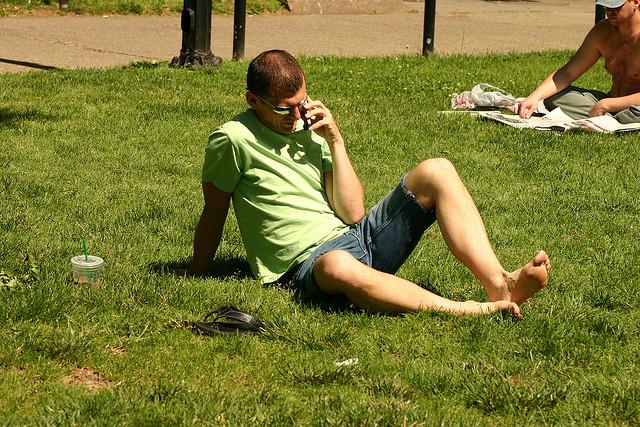Is the man happy?
Concise answer only. No. What kind of shoes does she have on?
Write a very short answer. None. What is the man doing?
Short answer required. Sitting. Is the man inside?
Short answer required. No. Is he wearing shoes?
Keep it brief. No. 